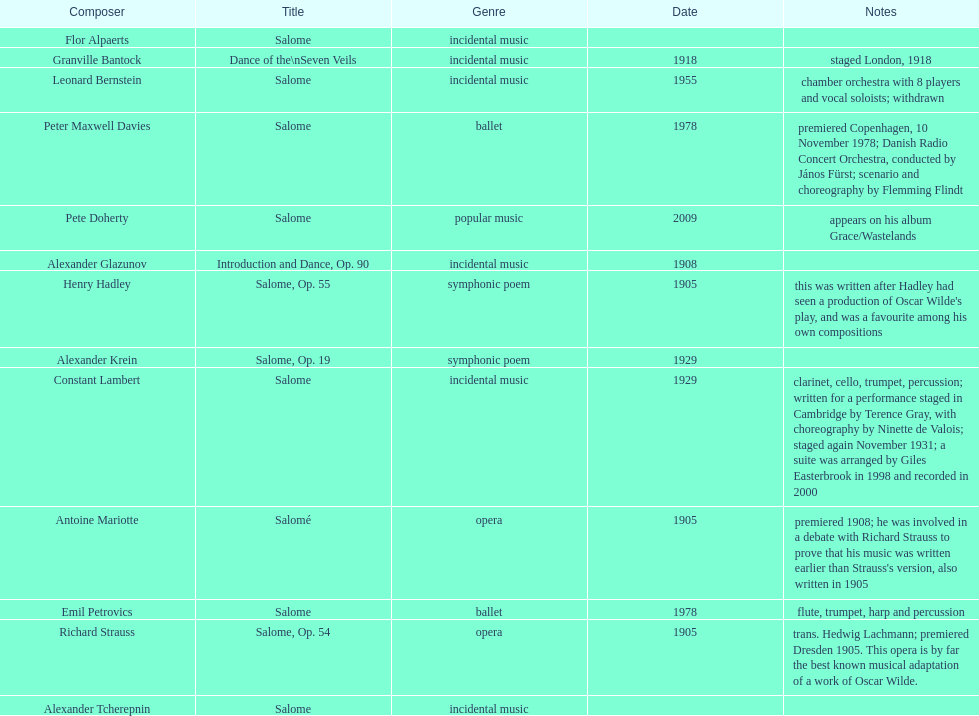What creation was authored following henry hadley's viewing of an oscar wilde stage production? Salome, Op. 55. 